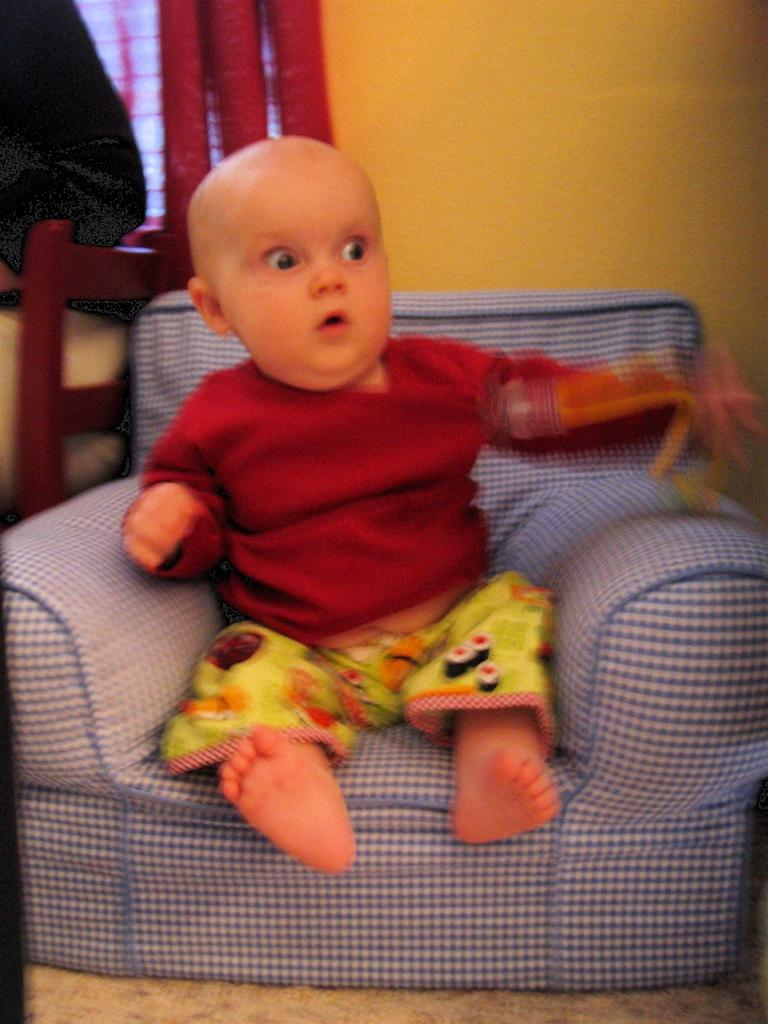What colors can be seen in the background of the image? There is a red curtain and a yellow wall in the background of the image. What is the baby in the image doing? The baby is sitting on a chair in the image. What color is the baby's shirt? The baby is wearing a red shirt. Can you hear the baby whistling in the image? There is no indication of sound in the image, so it cannot be determined if the baby is whistling or not. 